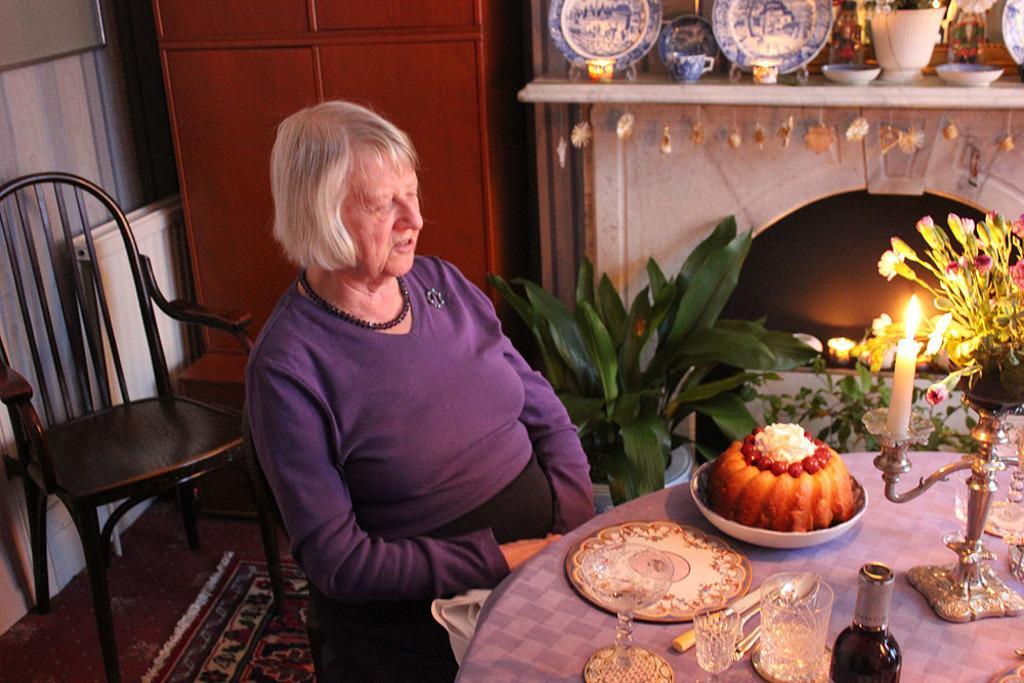Could you give a brief overview of what you see in this image? This is an inside view of a room. In the middle of the image there is a woman sitting on a chair facing towards the right side. In front of this woman there is a table which is covered with a cloth. On the table, I can see a plate, a bowl which consists of some food item, glasses, spoons, bottle, flower vase, candle and some other objects. On the left side there is a chair placed on the floor. In the background there is cupboard, beside there is a rack in which few plates, bowls and cups are placed. Behind the table there are few house plants. 